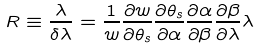<formula> <loc_0><loc_0><loc_500><loc_500>R \equiv \frac { \lambda } { \delta \lambda } = \frac { 1 } { w } \frac { \partial w } { \partial \theta _ { s } } \frac { \partial \theta _ { s } } { \partial \alpha } \frac { \partial \alpha } { \partial \beta } \frac { \partial \beta } { \partial \lambda } \lambda</formula> 